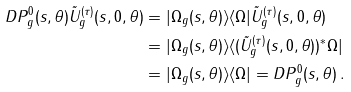Convert formula to latex. <formula><loc_0><loc_0><loc_500><loc_500>D P ^ { 0 } _ { g } ( s , \theta ) \tilde { U } _ { g } ^ { ( \tau ) } ( s , 0 , \theta ) & = | \Omega _ { g } ( s , \theta ) \rangle \langle \Omega | \tilde { U } _ { g } ^ { ( \tau ) } ( s , 0 , \theta ) \\ & = | \Omega _ { g } ( s , \theta ) \rangle \langle ( \tilde { U } _ { g } ^ { ( \tau ) } ( s , 0 , \theta ) ) ^ { * } \Omega | \\ & = | \Omega _ { g } ( s , \theta ) \rangle \langle \Omega | = D P ^ { 0 } _ { g } ( s , \theta ) \, .</formula> 